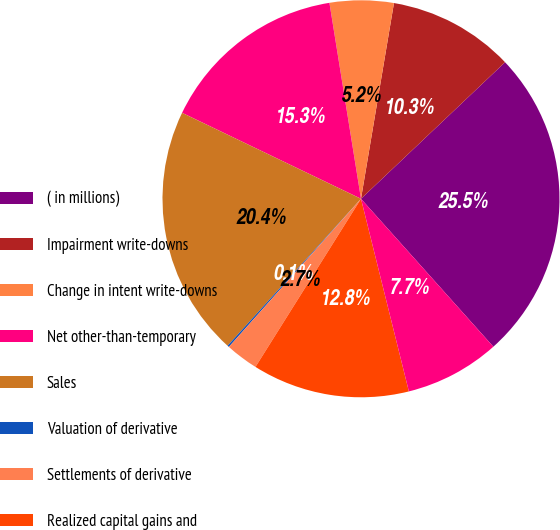<chart> <loc_0><loc_0><loc_500><loc_500><pie_chart><fcel>( in millions)<fcel>Impairment write-downs<fcel>Change in intent write-downs<fcel>Net other-than-temporary<fcel>Sales<fcel>Valuation of derivative<fcel>Settlements of derivative<fcel>Realized capital gains and<fcel>Income tax (expense) benefit<nl><fcel>25.46%<fcel>10.27%<fcel>5.2%<fcel>15.33%<fcel>20.4%<fcel>0.14%<fcel>2.67%<fcel>12.8%<fcel>7.74%<nl></chart> 